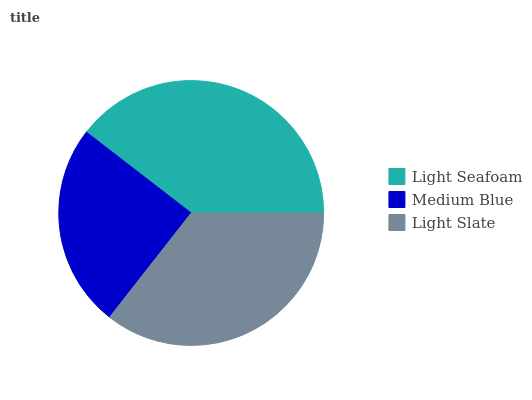Is Medium Blue the minimum?
Answer yes or no. Yes. Is Light Seafoam the maximum?
Answer yes or no. Yes. Is Light Slate the minimum?
Answer yes or no. No. Is Light Slate the maximum?
Answer yes or no. No. Is Light Slate greater than Medium Blue?
Answer yes or no. Yes. Is Medium Blue less than Light Slate?
Answer yes or no. Yes. Is Medium Blue greater than Light Slate?
Answer yes or no. No. Is Light Slate less than Medium Blue?
Answer yes or no. No. Is Light Slate the high median?
Answer yes or no. Yes. Is Light Slate the low median?
Answer yes or no. Yes. Is Light Seafoam the high median?
Answer yes or no. No. Is Medium Blue the low median?
Answer yes or no. No. 